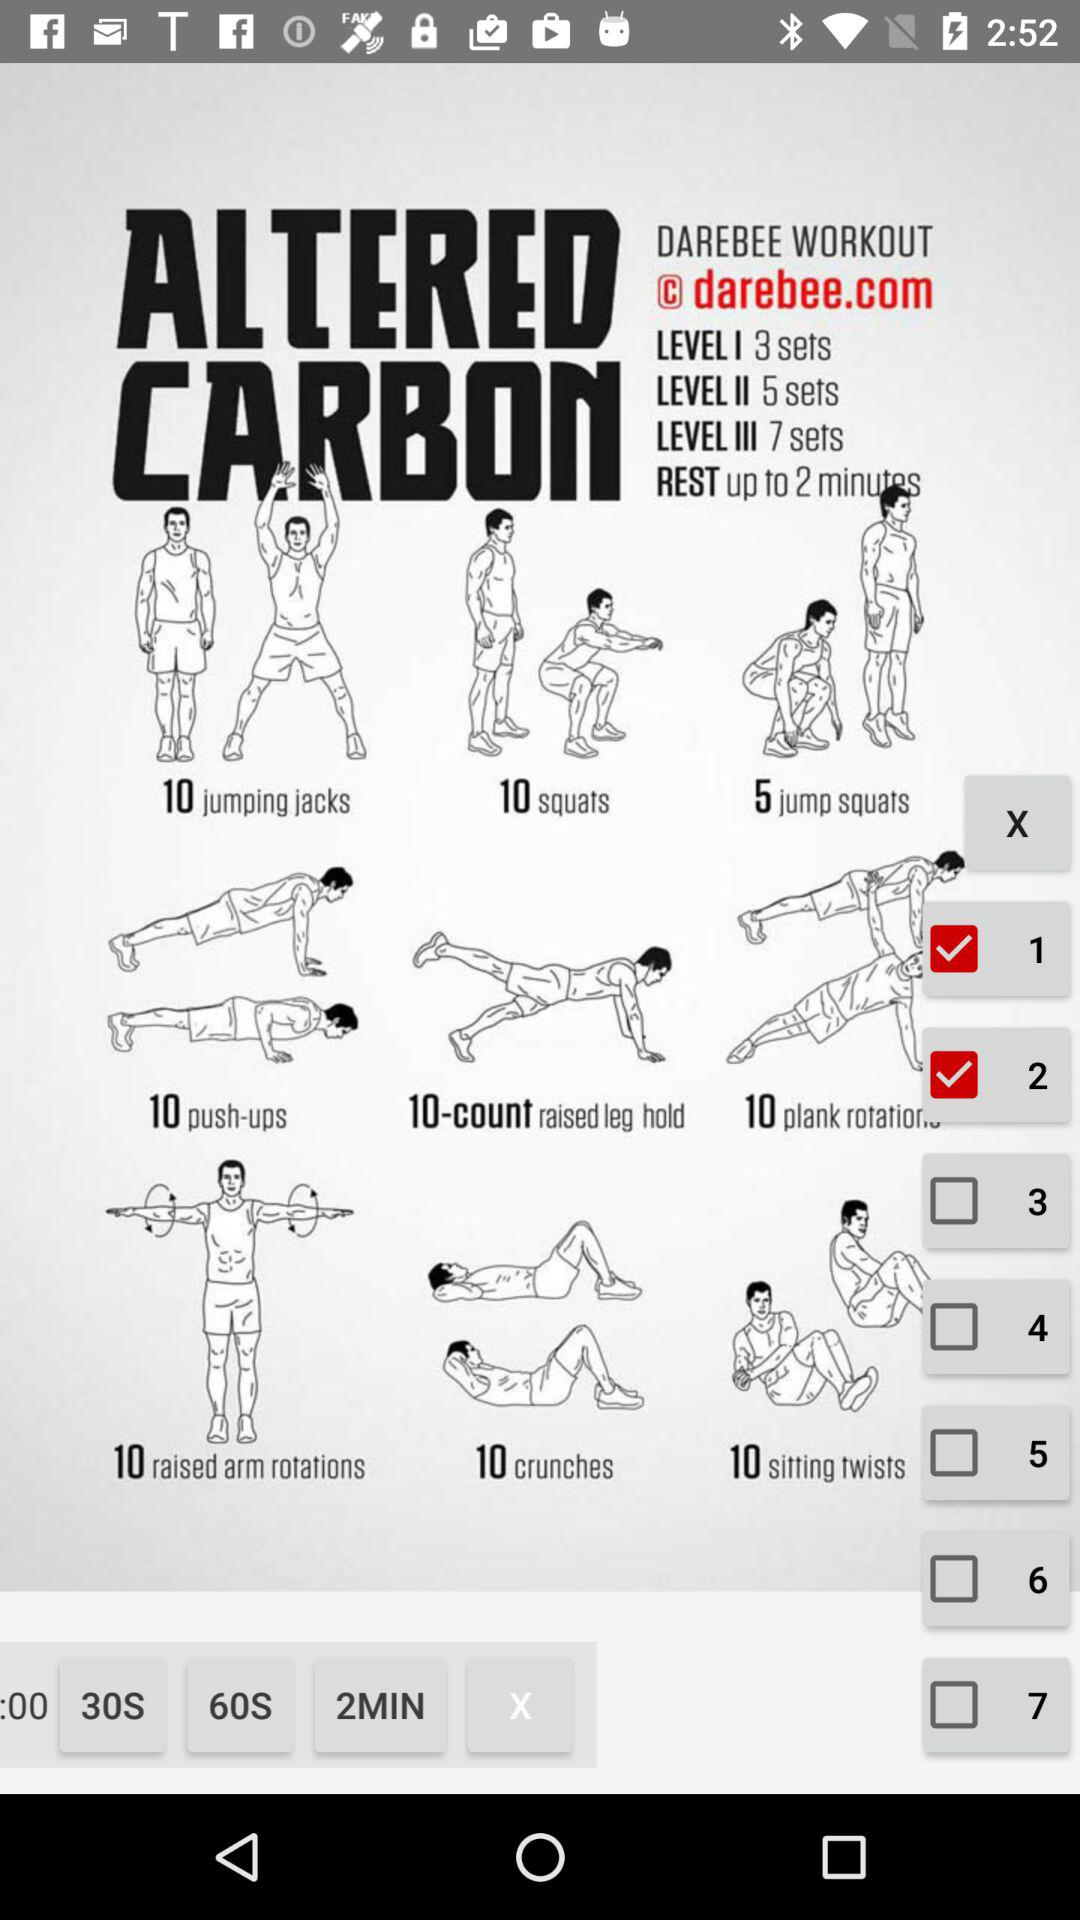How many calories does "Push-ups" burn?
When the provided information is insufficient, respond with <no answer>. <no answer> 